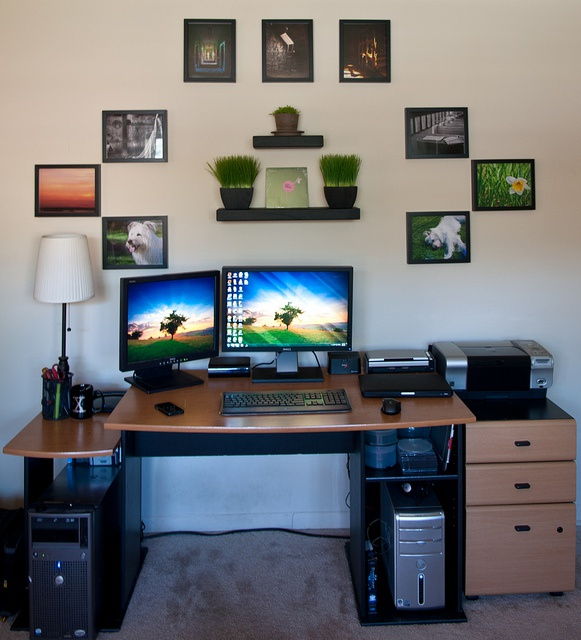Describe the objects in this image and their specific colors. I can see tv in tan, white, black, blue, and lightblue tones, tv in tan, black, white, blue, and darkgreen tones, keyboard in tan, gray, black, blue, and darkblue tones, potted plant in tan, black, and darkgreen tones, and potted plant in tan, black, darkgreen, and olive tones in this image. 